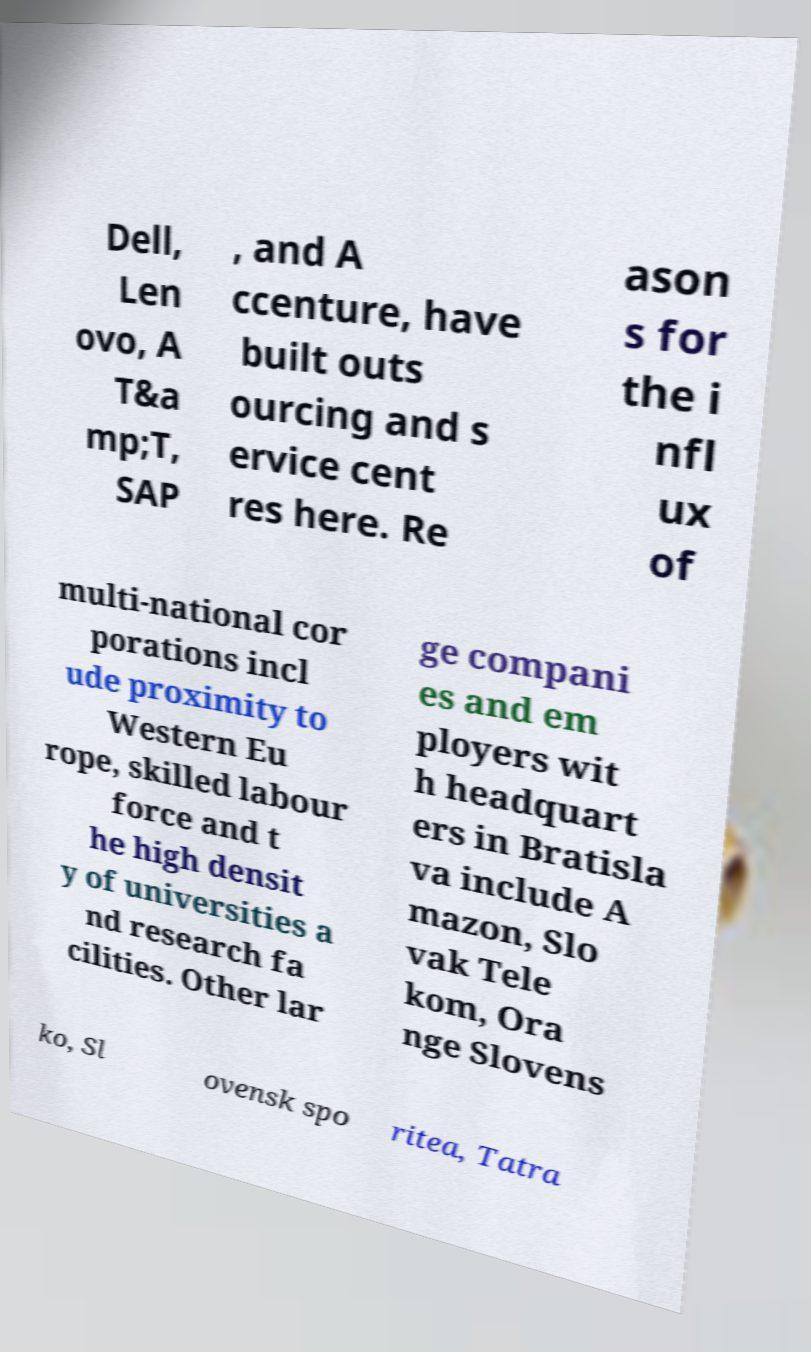Please read and relay the text visible in this image. What does it say? Dell, Len ovo, A T&a mp;T, SAP , and A ccenture, have built outs ourcing and s ervice cent res here. Re ason s for the i nfl ux of multi-national cor porations incl ude proximity to Western Eu rope, skilled labour force and t he high densit y of universities a nd research fa cilities. Other lar ge compani es and em ployers wit h headquart ers in Bratisla va include A mazon, Slo vak Tele kom, Ora nge Slovens ko, Sl ovensk spo ritea, Tatra 